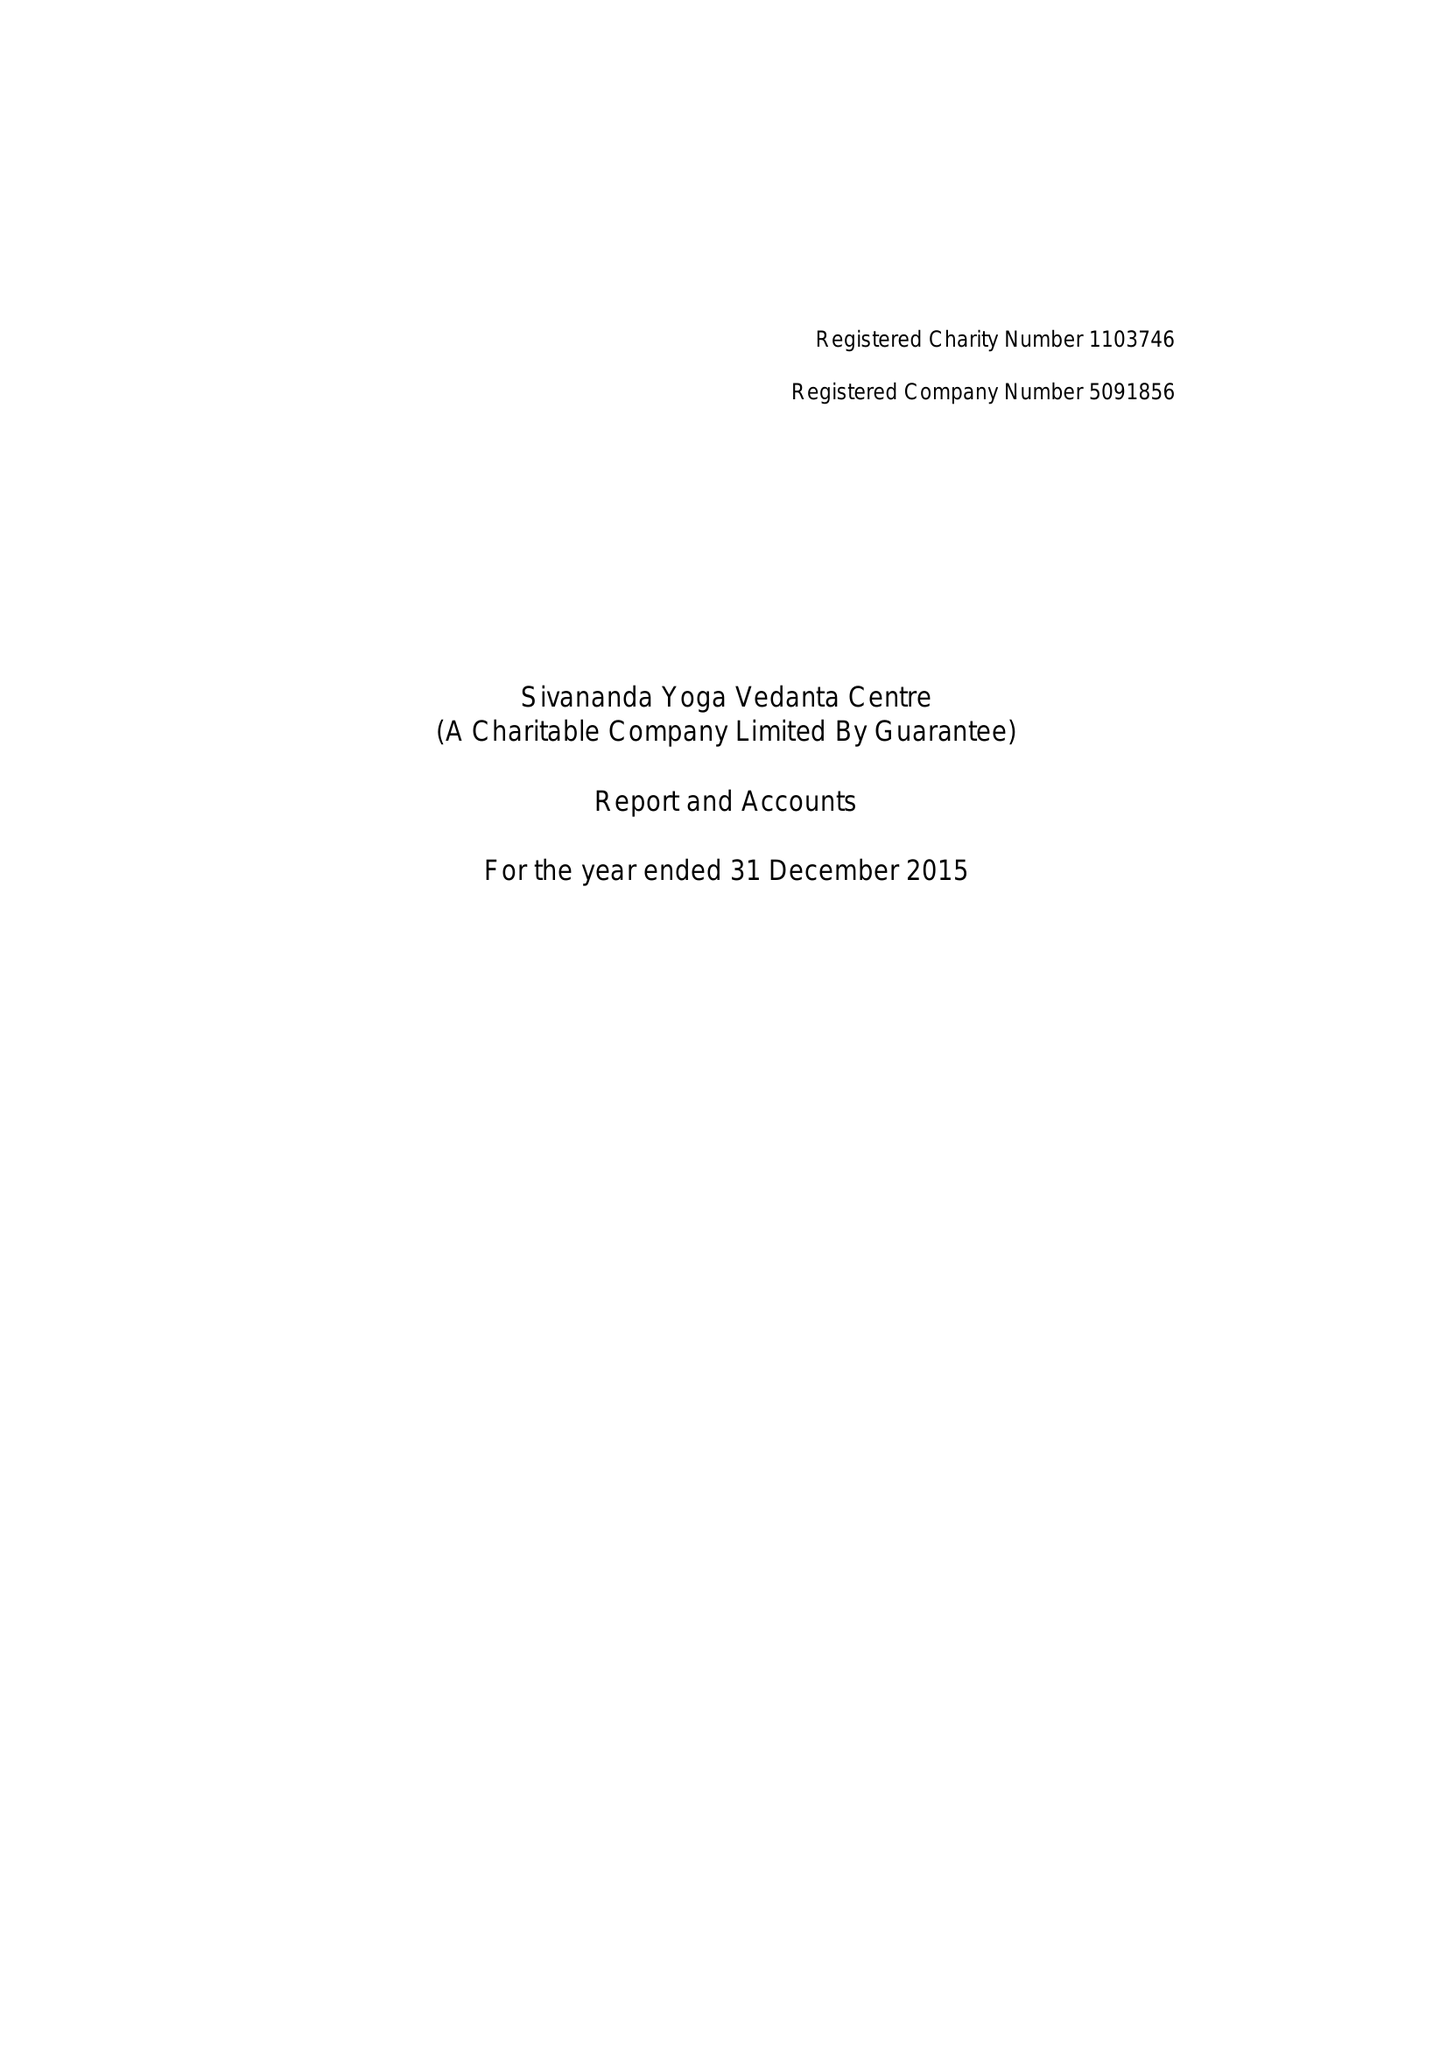What is the value for the report_date?
Answer the question using a single word or phrase. 2015-12-31 